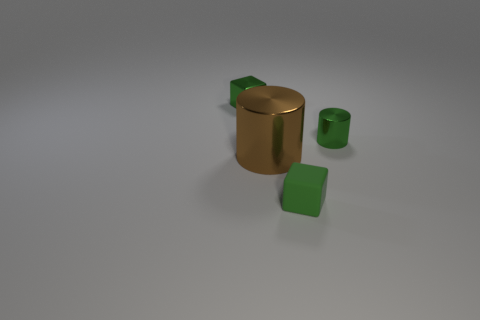What number of small cylinders are the same color as the metallic cube?
Offer a very short reply. 1. There is another small cube that is the same color as the small rubber cube; what is its material?
Your answer should be very brief. Metal. There is a shiny cylinder that is behind the big brown metallic cylinder; what is its size?
Give a very brief answer. Small. What number of things are either tiny green shiny things or green things left of the small green cylinder?
Offer a terse response. 3. How many other things are the same size as the green metallic block?
Keep it short and to the point. 2. What is the material of the tiny green object that is the same shape as the brown thing?
Provide a succinct answer. Metal. Is the number of tiny green cubes that are in front of the large brown object greater than the number of tiny green things?
Offer a very short reply. No. Are there any other things that have the same color as the small cylinder?
Provide a succinct answer. Yes. What is the shape of the tiny green thing that is made of the same material as the small cylinder?
Give a very brief answer. Cube. Does the cube in front of the green metal cube have the same material as the large cylinder?
Ensure brevity in your answer.  No. 